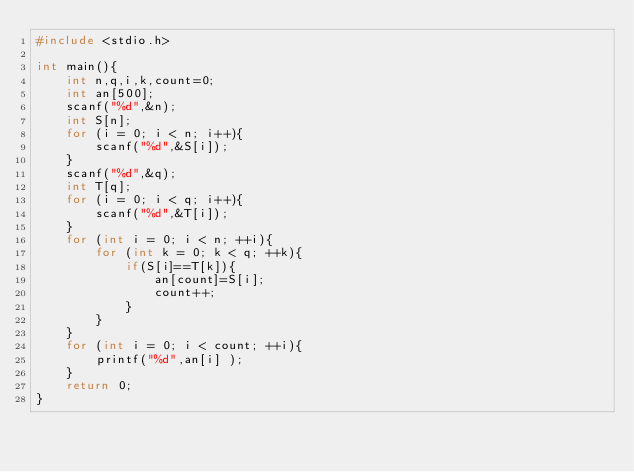Convert code to text. <code><loc_0><loc_0><loc_500><loc_500><_C++_>#include <stdio.h>  

int main(){
	int n,q,i,k,count=0;
	int an[500];
	scanf("%d",&n);
	int S[n];
	for (i = 0; i < n; i++){
		scanf("%d",&S[i]);
	}
	scanf("%d",&q);
	int T[q];
	for (i = 0; i < q; i++){
		scanf("%d",&T[i]);
	}
	for (int i = 0; i < n; ++i){
		for (int k = 0; k < q; ++k){
			if(S[i]==T[k]){
				an[count]=S[i];
				count++;
			}  
		}
	}
	for (int i = 0; i < count; ++i){
		printf("%d",an[i] );
	}
    return 0;  
}</code> 